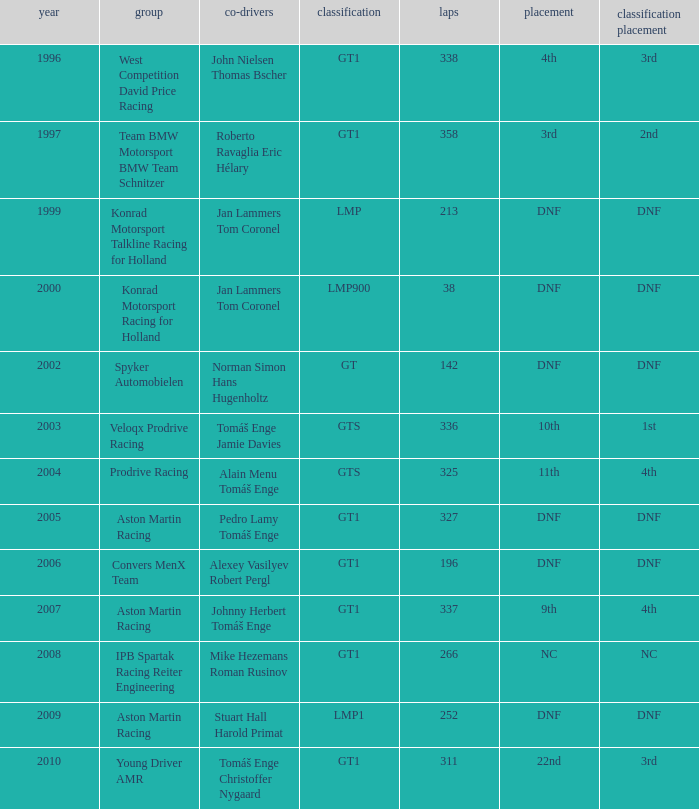Which position finished 3rd in class and completed less than 338 laps? 22nd. 